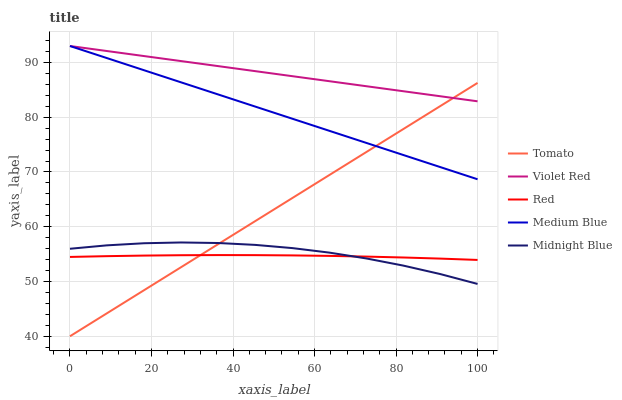Does Red have the minimum area under the curve?
Answer yes or no. Yes. Does Violet Red have the maximum area under the curve?
Answer yes or no. Yes. Does Medium Blue have the minimum area under the curve?
Answer yes or no. No. Does Medium Blue have the maximum area under the curve?
Answer yes or no. No. Is Medium Blue the smoothest?
Answer yes or no. Yes. Is Midnight Blue the roughest?
Answer yes or no. Yes. Is Violet Red the smoothest?
Answer yes or no. No. Is Violet Red the roughest?
Answer yes or no. No. Does Tomato have the lowest value?
Answer yes or no. Yes. Does Medium Blue have the lowest value?
Answer yes or no. No. Does Medium Blue have the highest value?
Answer yes or no. Yes. Does Midnight Blue have the highest value?
Answer yes or no. No. Is Midnight Blue less than Violet Red?
Answer yes or no. Yes. Is Violet Red greater than Red?
Answer yes or no. Yes. Does Red intersect Midnight Blue?
Answer yes or no. Yes. Is Red less than Midnight Blue?
Answer yes or no. No. Is Red greater than Midnight Blue?
Answer yes or no. No. Does Midnight Blue intersect Violet Red?
Answer yes or no. No. 